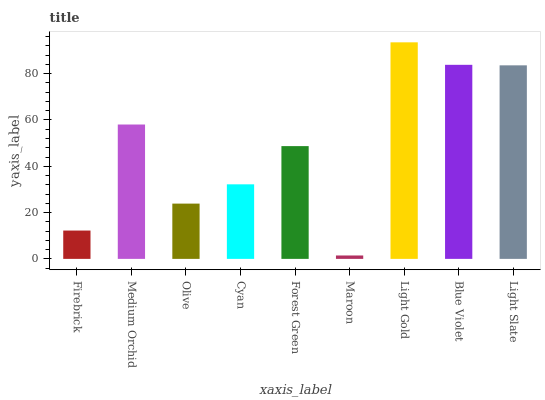Is Maroon the minimum?
Answer yes or no. Yes. Is Light Gold the maximum?
Answer yes or no. Yes. Is Medium Orchid the minimum?
Answer yes or no. No. Is Medium Orchid the maximum?
Answer yes or no. No. Is Medium Orchid greater than Firebrick?
Answer yes or no. Yes. Is Firebrick less than Medium Orchid?
Answer yes or no. Yes. Is Firebrick greater than Medium Orchid?
Answer yes or no. No. Is Medium Orchid less than Firebrick?
Answer yes or no. No. Is Forest Green the high median?
Answer yes or no. Yes. Is Forest Green the low median?
Answer yes or no. Yes. Is Firebrick the high median?
Answer yes or no. No. Is Cyan the low median?
Answer yes or no. No. 